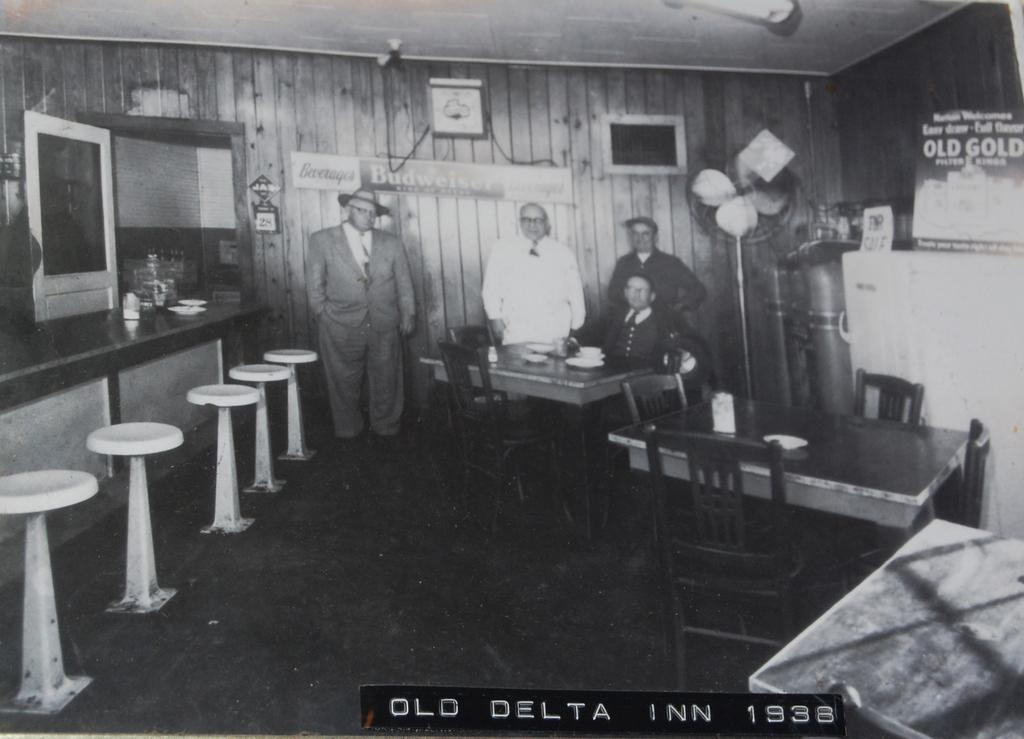What is the general activity taking place in the image? There are people standing in the image, which suggests some form of gathering or activity. Can you describe the position of one of the individuals in the image? There is a man seated on a chair in the image. What type of objects can be seen in the image? There are tools visible in the image. What is hanging on the wall in the image? There is a photo frame on the wall in the image. What type of wood is being used to teach the class in the image? There is no wood or teaching activity present in the image. How much honey is being consumed by the people in the image? There is no honey or consumption activity present in the image. 